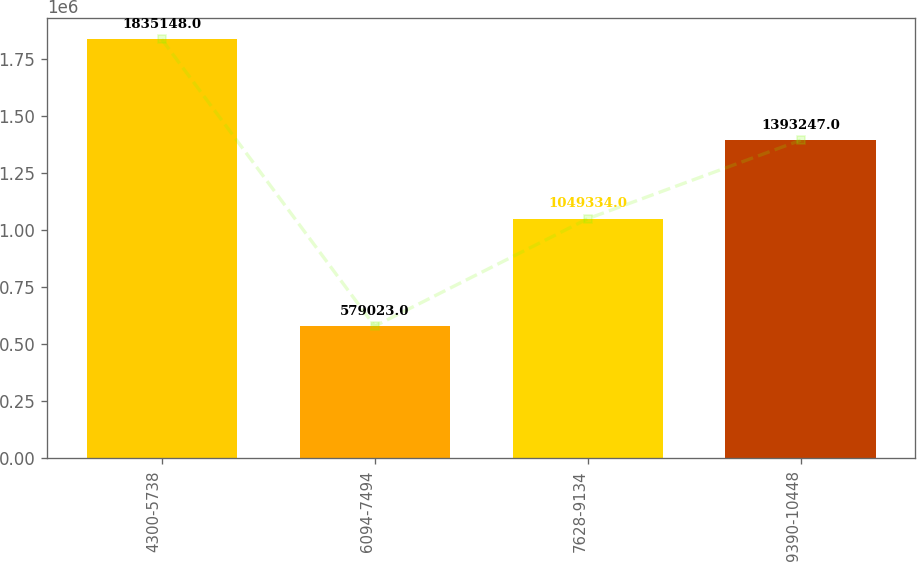Convert chart to OTSL. <chart><loc_0><loc_0><loc_500><loc_500><bar_chart><fcel>4300-5738<fcel>6094-7494<fcel>7628-9134<fcel>9390-10448<nl><fcel>1.83515e+06<fcel>579023<fcel>1.04933e+06<fcel>1.39325e+06<nl></chart> 